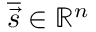Convert formula to latex. <formula><loc_0><loc_0><loc_500><loc_500>\overline { { \vec { s } } } \in \mathbb { R } ^ { n }</formula> 